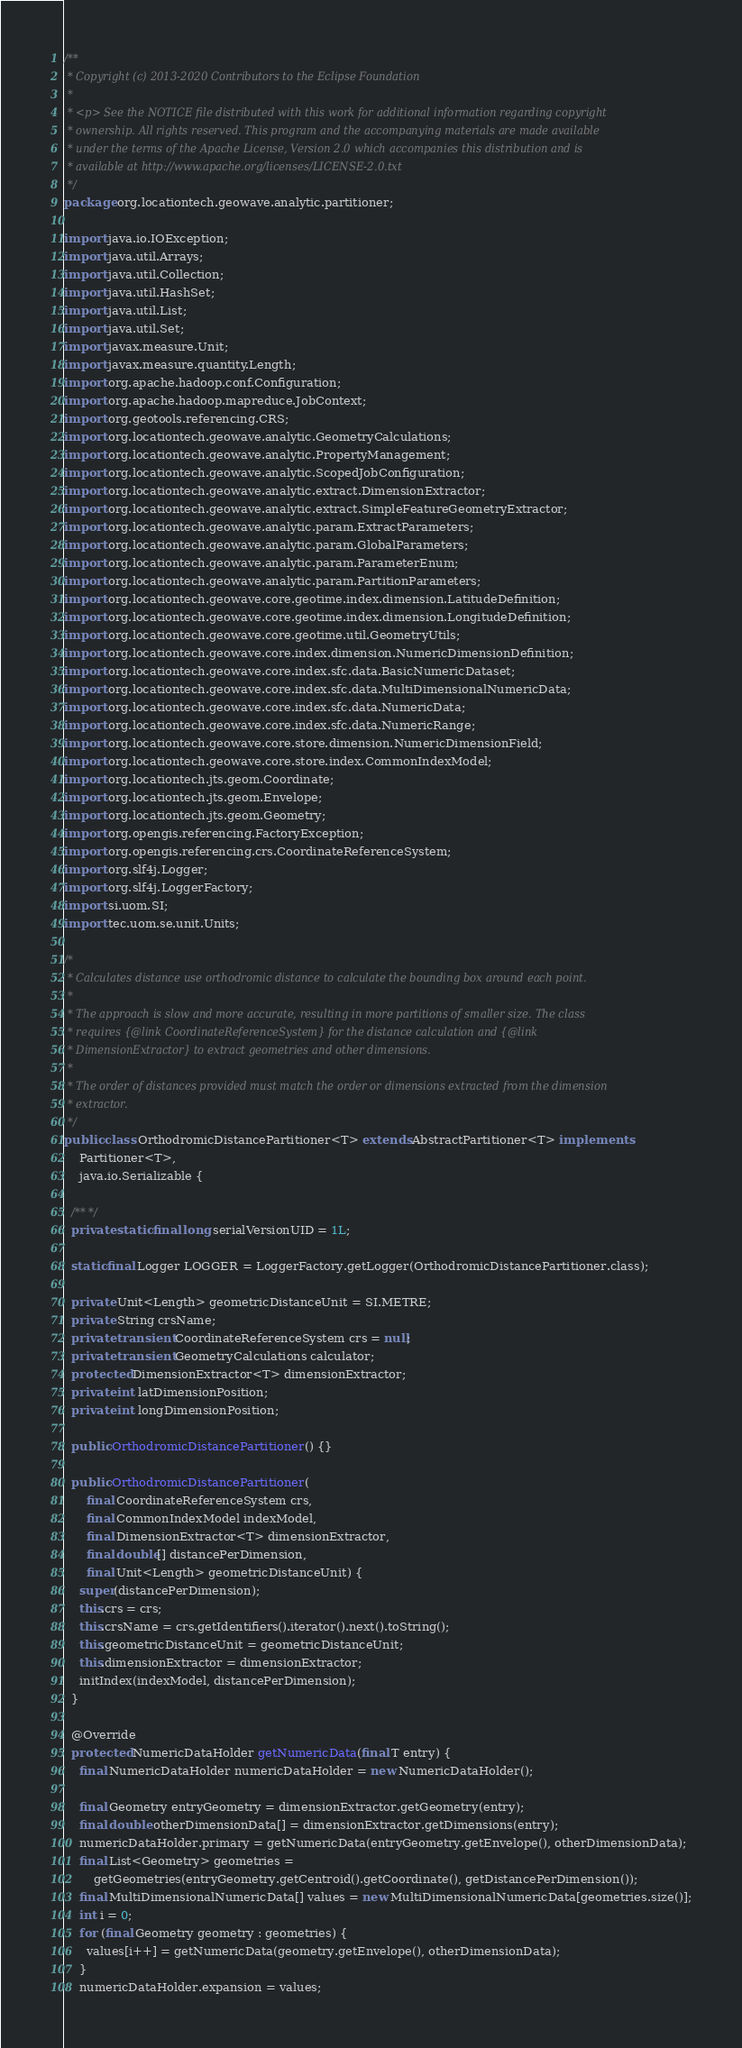Convert code to text. <code><loc_0><loc_0><loc_500><loc_500><_Java_>/**
 * Copyright (c) 2013-2020 Contributors to the Eclipse Foundation
 *
 * <p> See the NOTICE file distributed with this work for additional information regarding copyright
 * ownership. All rights reserved. This program and the accompanying materials are made available
 * under the terms of the Apache License, Version 2.0 which accompanies this distribution and is
 * available at http://www.apache.org/licenses/LICENSE-2.0.txt
 */
package org.locationtech.geowave.analytic.partitioner;

import java.io.IOException;
import java.util.Arrays;
import java.util.Collection;
import java.util.HashSet;
import java.util.List;
import java.util.Set;
import javax.measure.Unit;
import javax.measure.quantity.Length;
import org.apache.hadoop.conf.Configuration;
import org.apache.hadoop.mapreduce.JobContext;
import org.geotools.referencing.CRS;
import org.locationtech.geowave.analytic.GeometryCalculations;
import org.locationtech.geowave.analytic.PropertyManagement;
import org.locationtech.geowave.analytic.ScopedJobConfiguration;
import org.locationtech.geowave.analytic.extract.DimensionExtractor;
import org.locationtech.geowave.analytic.extract.SimpleFeatureGeometryExtractor;
import org.locationtech.geowave.analytic.param.ExtractParameters;
import org.locationtech.geowave.analytic.param.GlobalParameters;
import org.locationtech.geowave.analytic.param.ParameterEnum;
import org.locationtech.geowave.analytic.param.PartitionParameters;
import org.locationtech.geowave.core.geotime.index.dimension.LatitudeDefinition;
import org.locationtech.geowave.core.geotime.index.dimension.LongitudeDefinition;
import org.locationtech.geowave.core.geotime.util.GeometryUtils;
import org.locationtech.geowave.core.index.dimension.NumericDimensionDefinition;
import org.locationtech.geowave.core.index.sfc.data.BasicNumericDataset;
import org.locationtech.geowave.core.index.sfc.data.MultiDimensionalNumericData;
import org.locationtech.geowave.core.index.sfc.data.NumericData;
import org.locationtech.geowave.core.index.sfc.data.NumericRange;
import org.locationtech.geowave.core.store.dimension.NumericDimensionField;
import org.locationtech.geowave.core.store.index.CommonIndexModel;
import org.locationtech.jts.geom.Coordinate;
import org.locationtech.jts.geom.Envelope;
import org.locationtech.jts.geom.Geometry;
import org.opengis.referencing.FactoryException;
import org.opengis.referencing.crs.CoordinateReferenceSystem;
import org.slf4j.Logger;
import org.slf4j.LoggerFactory;
import si.uom.SI;
import tec.uom.se.unit.Units;

/*
 * Calculates distance use orthodromic distance to calculate the bounding box around each point.
 *
 * The approach is slow and more accurate, resulting in more partitions of smaller size. The class
 * requires {@link CoordinateReferenceSystem} for the distance calculation and {@link
 * DimensionExtractor} to extract geometries and other dimensions.
 *
 * The order of distances provided must match the order or dimensions extracted from the dimension
 * extractor.
 */
public class OrthodromicDistancePartitioner<T> extends AbstractPartitioner<T> implements
    Partitioner<T>,
    java.io.Serializable {

  /** */
  private static final long serialVersionUID = 1L;

  static final Logger LOGGER = LoggerFactory.getLogger(OrthodromicDistancePartitioner.class);

  private Unit<Length> geometricDistanceUnit = SI.METRE;
  private String crsName;
  private transient CoordinateReferenceSystem crs = null;
  private transient GeometryCalculations calculator;
  protected DimensionExtractor<T> dimensionExtractor;
  private int latDimensionPosition;
  private int longDimensionPosition;

  public OrthodromicDistancePartitioner() {}

  public OrthodromicDistancePartitioner(
      final CoordinateReferenceSystem crs,
      final CommonIndexModel indexModel,
      final DimensionExtractor<T> dimensionExtractor,
      final double[] distancePerDimension,
      final Unit<Length> geometricDistanceUnit) {
    super(distancePerDimension);
    this.crs = crs;
    this.crsName = crs.getIdentifiers().iterator().next().toString();
    this.geometricDistanceUnit = geometricDistanceUnit;
    this.dimensionExtractor = dimensionExtractor;
    initIndex(indexModel, distancePerDimension);
  }

  @Override
  protected NumericDataHolder getNumericData(final T entry) {
    final NumericDataHolder numericDataHolder = new NumericDataHolder();

    final Geometry entryGeometry = dimensionExtractor.getGeometry(entry);
    final double otherDimensionData[] = dimensionExtractor.getDimensions(entry);
    numericDataHolder.primary = getNumericData(entryGeometry.getEnvelope(), otherDimensionData);
    final List<Geometry> geometries =
        getGeometries(entryGeometry.getCentroid().getCoordinate(), getDistancePerDimension());
    final MultiDimensionalNumericData[] values = new MultiDimensionalNumericData[geometries.size()];
    int i = 0;
    for (final Geometry geometry : geometries) {
      values[i++] = getNumericData(geometry.getEnvelope(), otherDimensionData);
    }
    numericDataHolder.expansion = values;</code> 